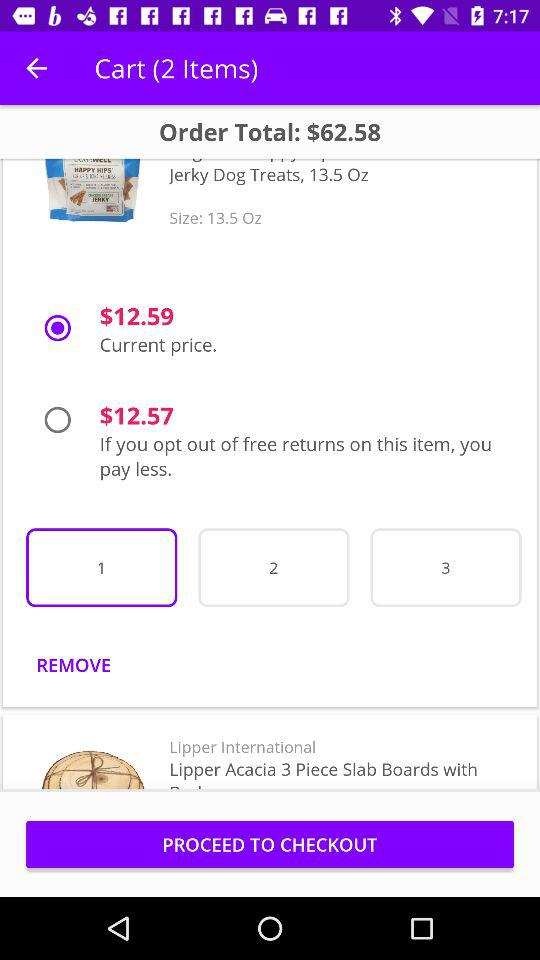What's the current price? The current price is $12.59. 